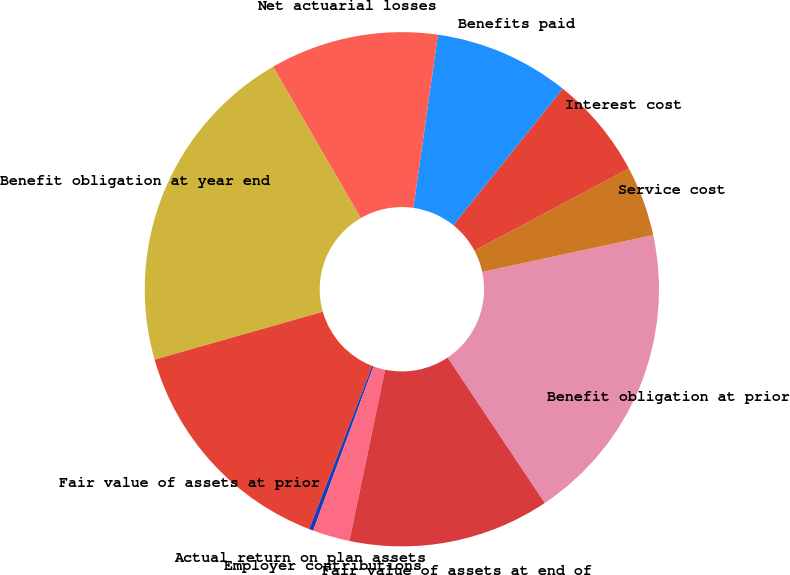Convert chart to OTSL. <chart><loc_0><loc_0><loc_500><loc_500><pie_chart><fcel>Benefit obligation at prior<fcel>Service cost<fcel>Interest cost<fcel>Benefits paid<fcel>Net actuarial losses<fcel>Benefit obligation at year end<fcel>Fair value of assets at prior<fcel>Actual return on plan assets<fcel>Employer contributions<fcel>Fair value of assets at end of<nl><fcel>19.0%<fcel>4.4%<fcel>6.46%<fcel>8.52%<fcel>10.59%<fcel>21.06%<fcel>14.71%<fcel>0.27%<fcel>2.33%<fcel>12.65%<nl></chart> 